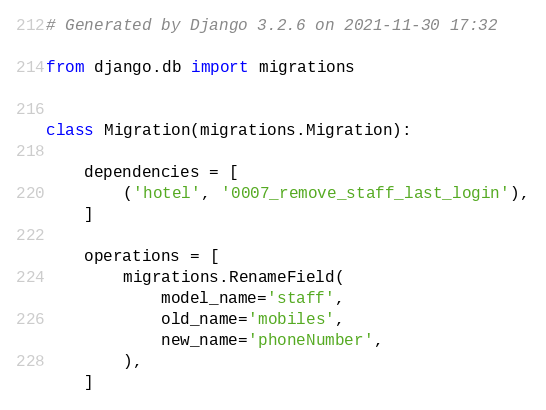<code> <loc_0><loc_0><loc_500><loc_500><_Python_># Generated by Django 3.2.6 on 2021-11-30 17:32

from django.db import migrations


class Migration(migrations.Migration):

    dependencies = [
        ('hotel', '0007_remove_staff_last_login'),
    ]

    operations = [
        migrations.RenameField(
            model_name='staff',
            old_name='mobiles',
            new_name='phoneNumber',
        ),
    ]
</code> 